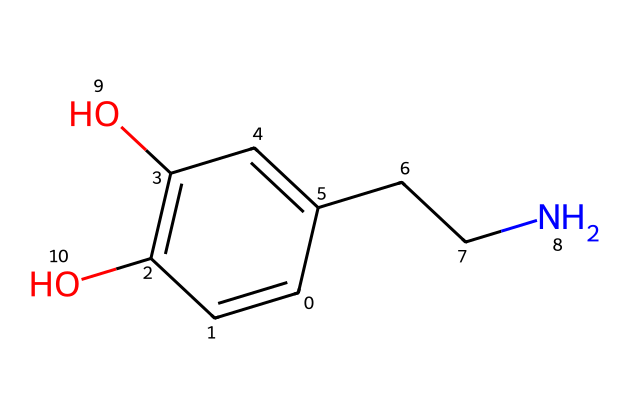What is the name of this chemical? The chemical structure resembles that of dopamine, which is a known neurotransmitter associated with pleasure and reward.
Answer: dopamine How many carbon atoms are in this molecule? By examining the SMILES representation, we can count 8 carbon atoms present in the structure.
Answer: 8 How many hydroxyl groups (–OH) are present? The structure shows two –OH groups attached to the aromatic ring, indicating the presence of two hydroxyl groups.
Answer: 2 What functional groups can be identified in this structure? The chemical has hydroxyl (–OH) and amine (–NH) functional groups, categorized based on their structure and bonding patterns.
Answer: hydroxyl and amine What is the degree of unsaturation in this compound? The degree of unsaturation can be calculated by considering the ring and double bonds present in the chemical structure. There is one ring and two double bonds, so the degree of unsaturation is 3.
Answer: 3 Is this chemical polar or nonpolar? Given the presence of hydroxyl groups, which increase polarity, and the amine group, this molecule is classified as polar.
Answer: polar 